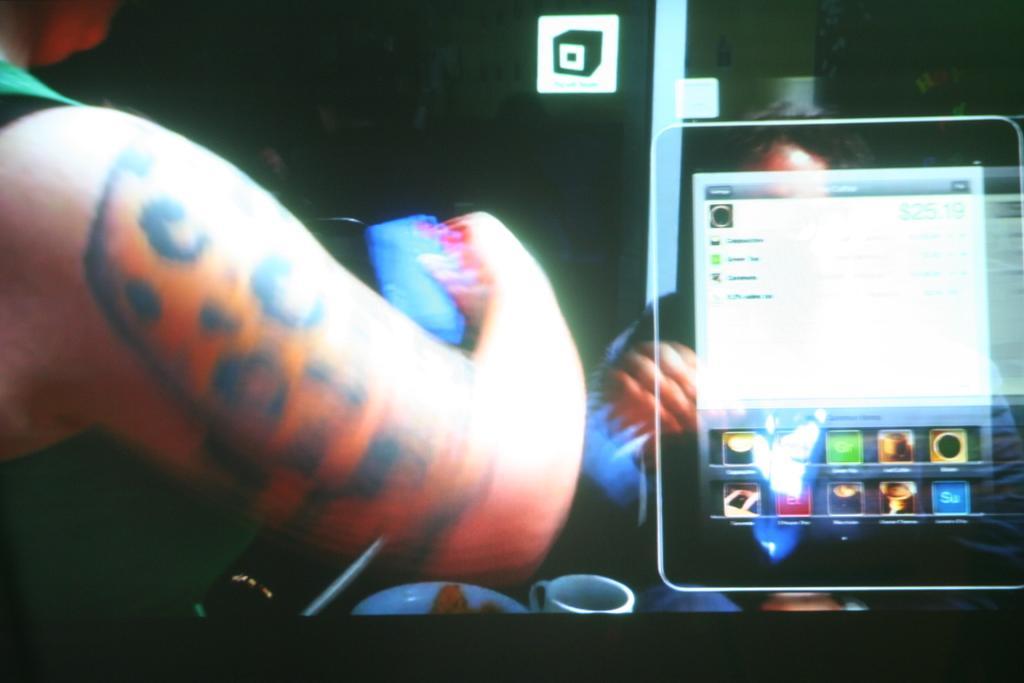Could you give a brief overview of what you see in this image? On the left side, there is a person. On the right side, there is a screen. Beside this screen, there is a person. And the background is dark in color. 